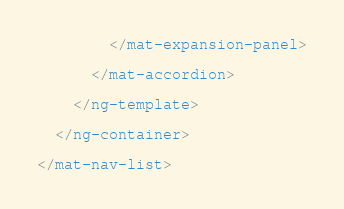<code> <loc_0><loc_0><loc_500><loc_500><_HTML_>
        </mat-expansion-panel>

      </mat-accordion>

    </ng-template>

  </ng-container>

</mat-nav-list></code> 